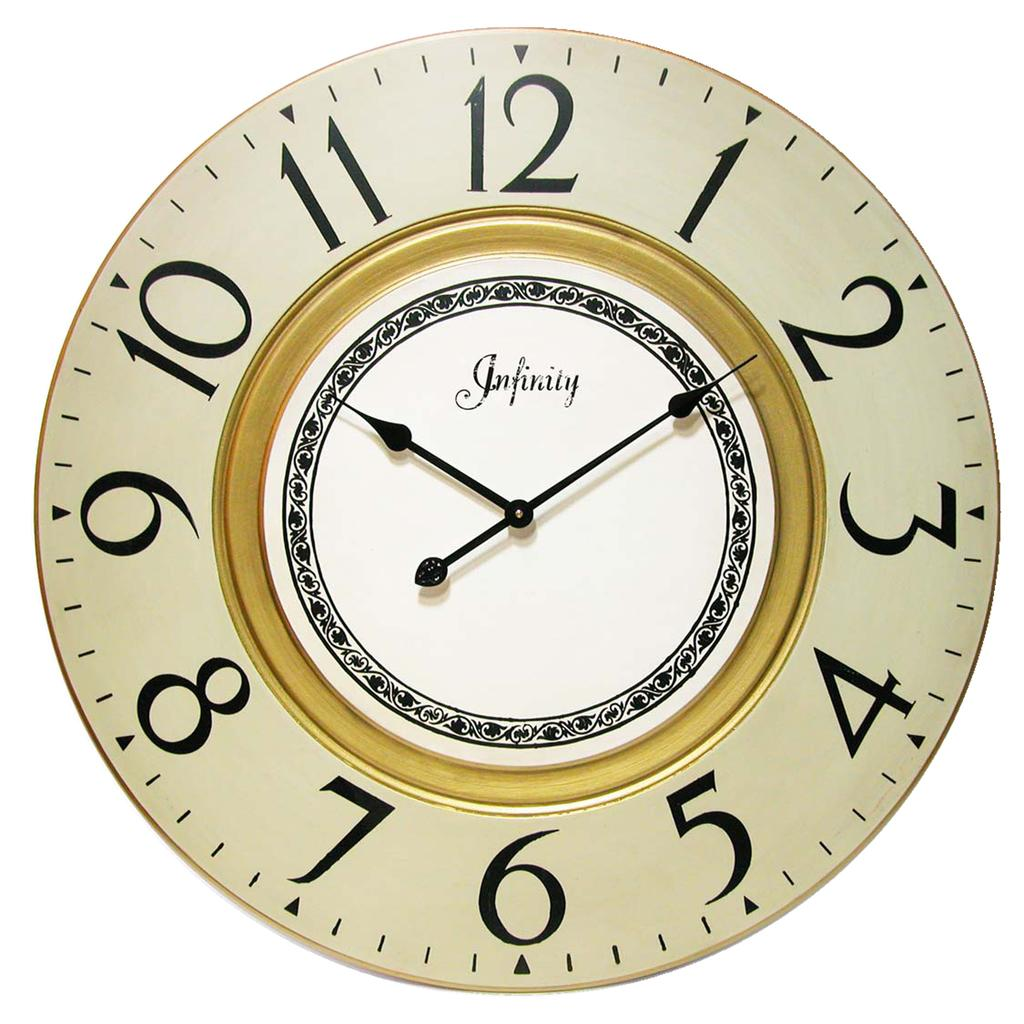<image>
Summarize the visual content of the image. the words 1 to 12 on the front of a clock 